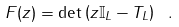<formula> <loc_0><loc_0><loc_500><loc_500>F ( z ) = \det \left ( z { \mathbb { I } } _ { L } - T _ { L } \right ) \ .</formula> 